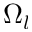Convert formula to latex. <formula><loc_0><loc_0><loc_500><loc_500>\Omega _ { l }</formula> 